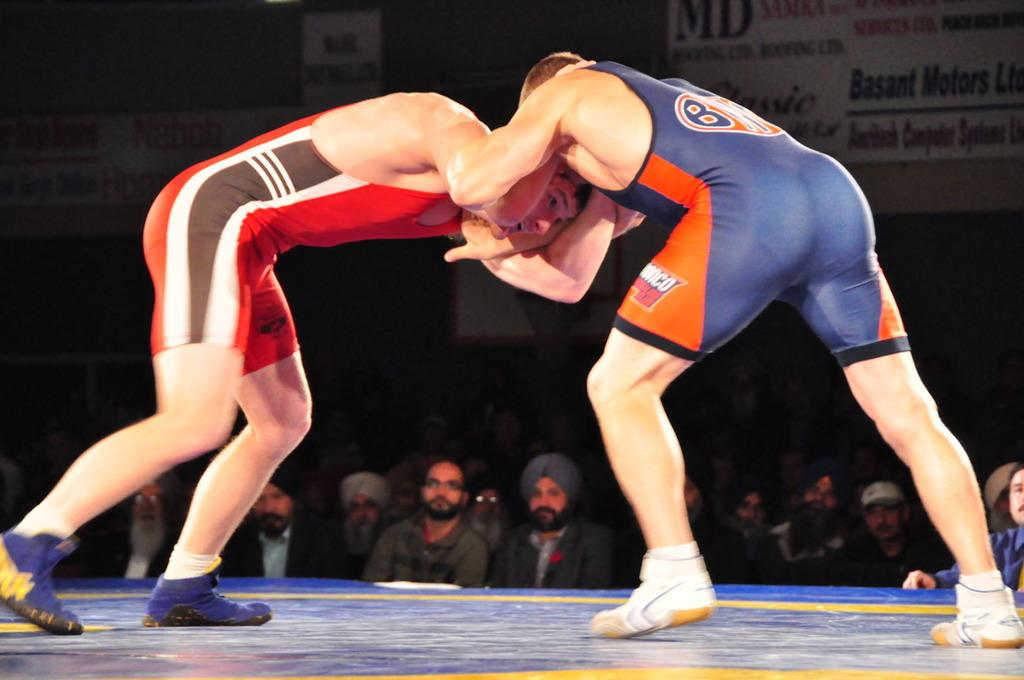Provide a one-sentence caption for the provided image. The man in the blue and orange wrestling outfit had a B on it. 